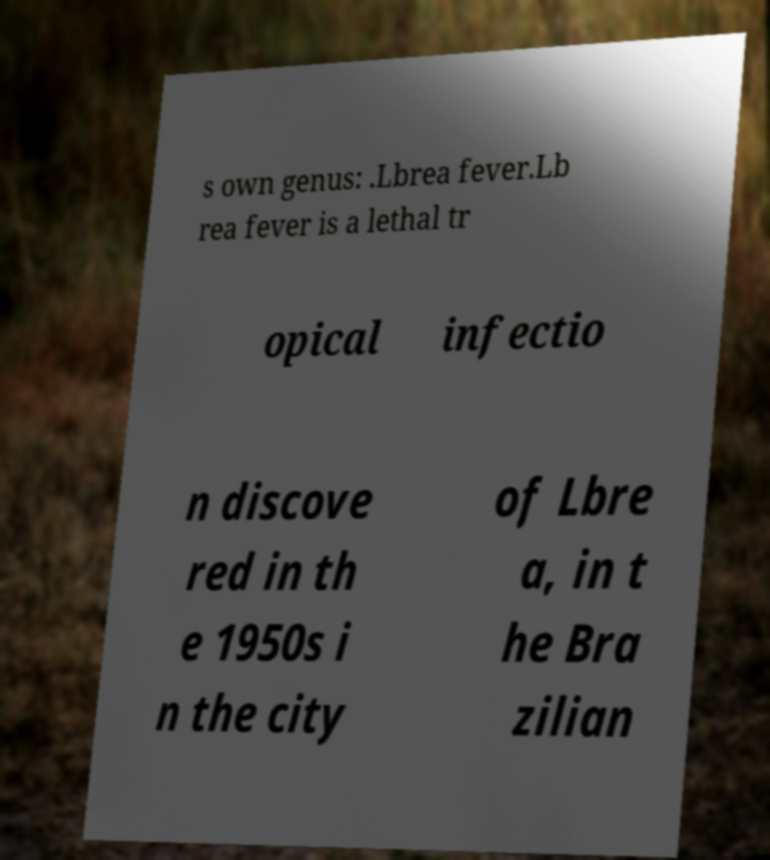Please read and relay the text visible in this image. What does it say? s own genus: .Lbrea fever.Lb rea fever is a lethal tr opical infectio n discove red in th e 1950s i n the city of Lbre a, in t he Bra zilian 